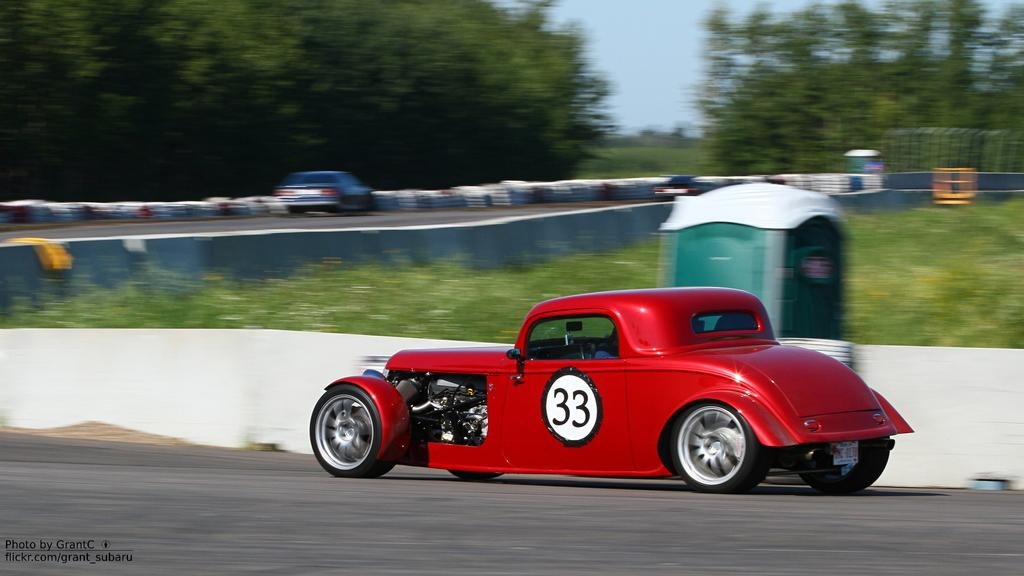What color is the car in the image? The car in the image is red. Where is the red car located? The red car is on a road. What is behind the red car? There is a garden behind the red car. What is the garden enclosed by? The garden is inside a fence. What is next to the road where the red car is located? There is another road next to the garden. What can be seen in the distance in the image? Trees are visible in the background of the image. What is visible above the trees and garden in the image? The sky is visible in the image. What things does the red car crush while driving on the road? The red car is not shown driving or crushing anything in the image. 